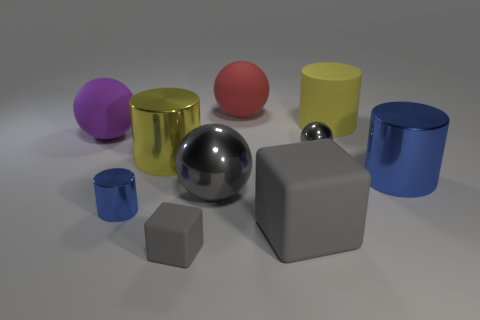If I were to reach out and touch the objects, what different textures would I feel? Your sense of touch would experience a range of textures: the smoothness and coolness of what looks like metallic surfaces on the gold and silver objects, a rubbery resistance on the colored matte surfaces, and an even smoother, plasticky feel on the objects with shinier, perhaps lacquered, finishes. Which object do you think would feel the heaviest and why? Judging by appearance, the large gray cube would likely feel the heaviest due to its size and the solid edges suggesting a dense composition. Mass is often associated with volume, and this cube has the largest volume amongst the shapes presented. 